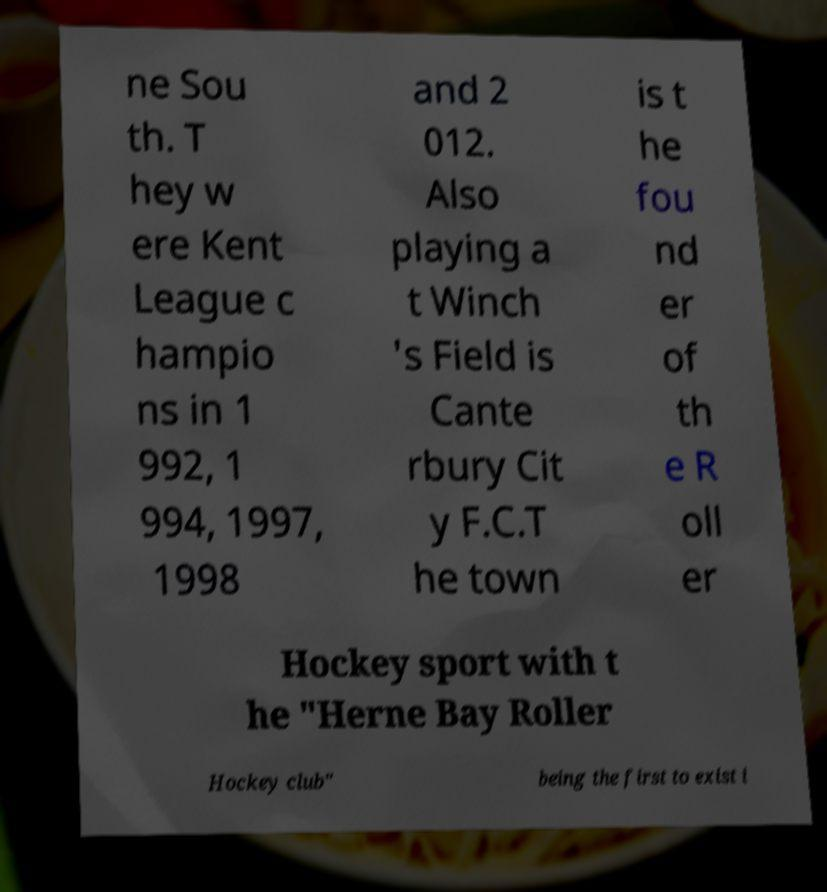Please read and relay the text visible in this image. What does it say? ne Sou th. T hey w ere Kent League c hampio ns in 1 992, 1 994, 1997, 1998 and 2 012. Also playing a t Winch 's Field is Cante rbury Cit y F.C.T he town is t he fou nd er of th e R oll er Hockey sport with t he "Herne Bay Roller Hockey club" being the first to exist i 